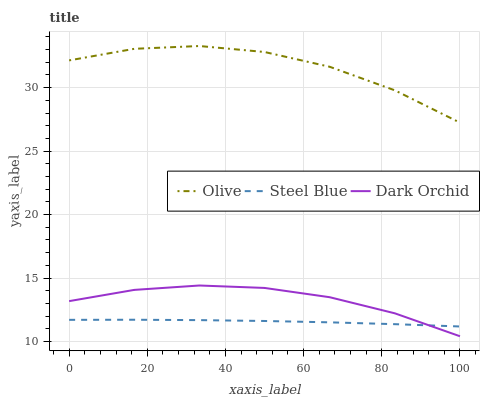Does Steel Blue have the minimum area under the curve?
Answer yes or no. Yes. Does Olive have the maximum area under the curve?
Answer yes or no. Yes. Does Dark Orchid have the minimum area under the curve?
Answer yes or no. No. Does Dark Orchid have the maximum area under the curve?
Answer yes or no. No. Is Steel Blue the smoothest?
Answer yes or no. Yes. Is Olive the roughest?
Answer yes or no. Yes. Is Dark Orchid the smoothest?
Answer yes or no. No. Is Dark Orchid the roughest?
Answer yes or no. No. Does Dark Orchid have the lowest value?
Answer yes or no. Yes. Does Steel Blue have the lowest value?
Answer yes or no. No. Does Olive have the highest value?
Answer yes or no. Yes. Does Dark Orchid have the highest value?
Answer yes or no. No. Is Steel Blue less than Olive?
Answer yes or no. Yes. Is Olive greater than Steel Blue?
Answer yes or no. Yes. Does Steel Blue intersect Dark Orchid?
Answer yes or no. Yes. Is Steel Blue less than Dark Orchid?
Answer yes or no. No. Is Steel Blue greater than Dark Orchid?
Answer yes or no. No. Does Steel Blue intersect Olive?
Answer yes or no. No. 